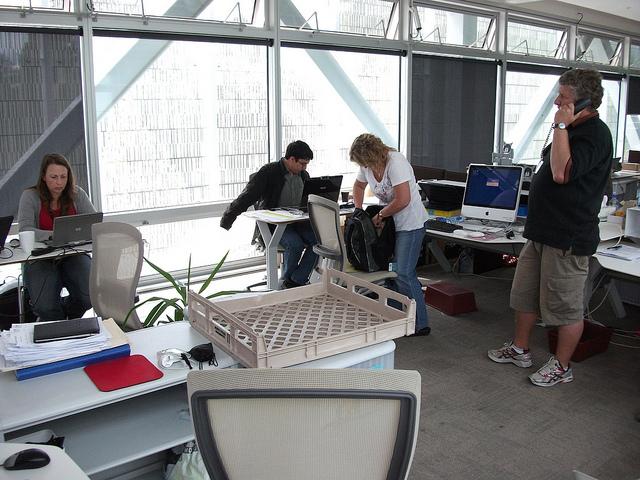How many girls are there?
Quick response, please. 2. Are the people interacting with each other?
Quick response, please. No. Is there natural light in the room?
Give a very brief answer. Yes. 